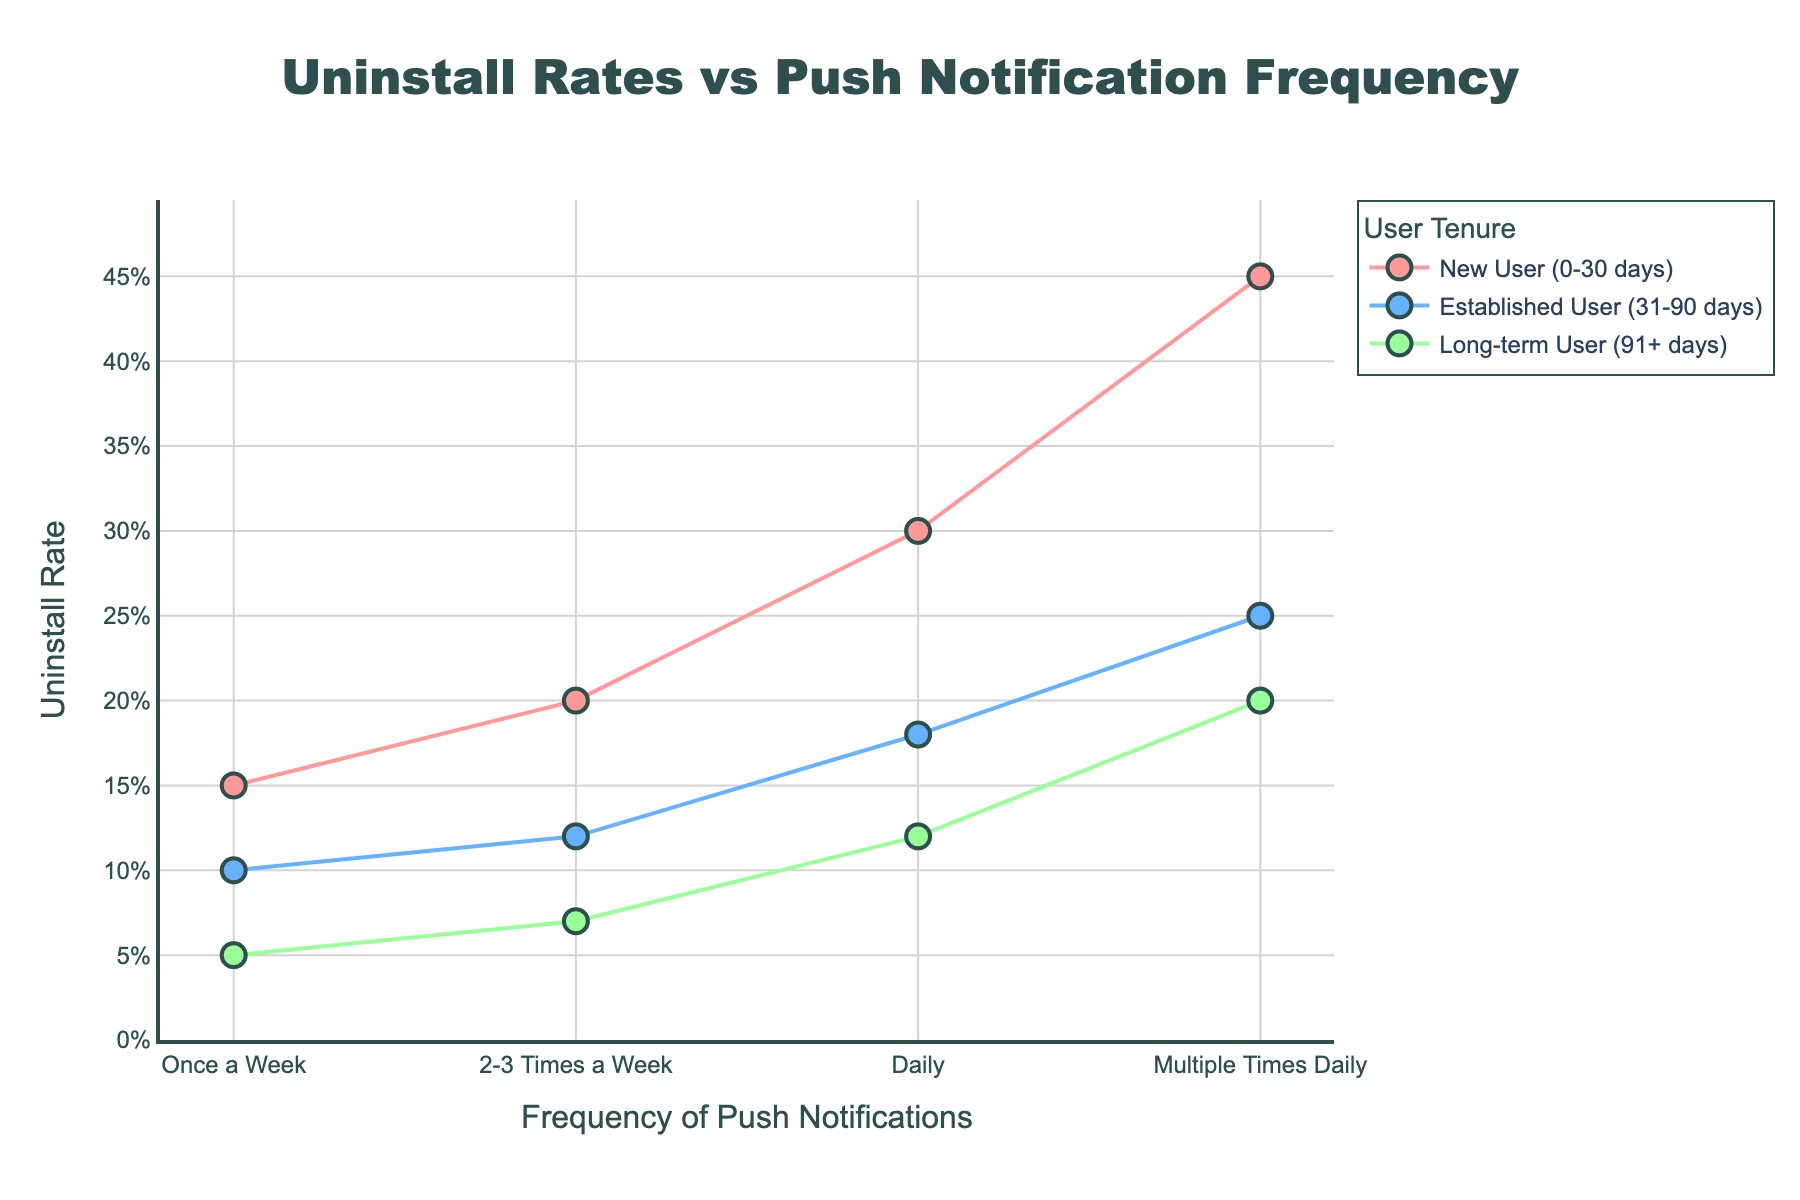what is the uninstall rate for new users who receive notifications once a week? The figure shows the uninstall rate for new users who receive notifications once a week. Referring to the data on the plot, the corresponding point for "Once a Week" under "New User (0-30 days)" indicates an uninstall rate of 15%.
Answer: 15% what is the title of the plot? The title of the plot is prominently displayed at the top, providing an overview of what the plot represents. It reads, "Uninstall Rates vs Push Notification Frequency".
Answer: Uninstall Rates vs Push Notification Frequency which group has the highest uninstall rate? The highest uninstall rate can be located by identifying the peak value on the y-axis and checking which user tenure and notification frequency it corresponds to. From the plot, "New User (0-30 days)" with "Multiple Times Daily" notifications has the highest uninstall rate of 45%.
Answer: New User (0-30 days) with Multiple Times Daily how much higher is the uninstall rate for new users receiving notifications daily compared to long-term users receiving notifications daily? First, find the uninstall rate for new users receiving notifications daily, which is 30%. Then, find the rate for long-term users receiving notifications daily, which is 12%. Subtract the latter from the former: 30% - 12% = 18%.
Answer: 18% does the uninstall rate generally increase or decrease with the frequency of notifications? By observing the trends of the plotted lines for different user tenures, it is clear that as the frequency of push notifications increases, the uninstall rate also increases for all user tenure groups.
Answer: Increase how does the uninstall rate for established users receiving notifications 2-3 times a week compare to new users receiving notifications once a week? The uninstall rate for established users receiving notifications 2-3 times a week is 12%. For new users receiving notifications once a week, it is 15%. Therefore, the rate for established users is lower.
Answer: Lower which user tenure group has the lowest uninstall rate for any notification frequency? Identify the lowest point on the y-axis and check its corresponding user tenure and notification frequency. The lowest uninstall rate is 5%, which belongs to "Long-term User (91+ days)" receiving notifications once a week.
Answer: Long-term User (91+ days) with Once a Week compare the uninstall rate for established users receiving daily notifications to that of new users receiving multiple times daily notifications. The uninstall rate for established users receiving daily notifications is 18%, whereas for new users receiving notifications multiple times daily, it is 45%. Thus, the rate for new users is significantly higher.
Answer: Higher what trend can you observe in the uninstall rate for long-term users as the frequency of push notifications increases? For long-term users, observe the points along the x-axis from left to right. The uninstall rate increases steadily from 5% (Once a Week) to 20% (Multiple Times Daily) as the frequency of notifications increases.
Answer: Increases among new users and established users, who has a smaller increase in uninstall rate when push notification frequency changes from daily to multiple times daily? Identify the uninstall rates for new and established users for daily and multiple times daily notifications. New users: 30% to 45% (increase of 15%). Established users: 18% to 25% (increase of 7%). The increase is smaller for established users.
Answer: Established users 